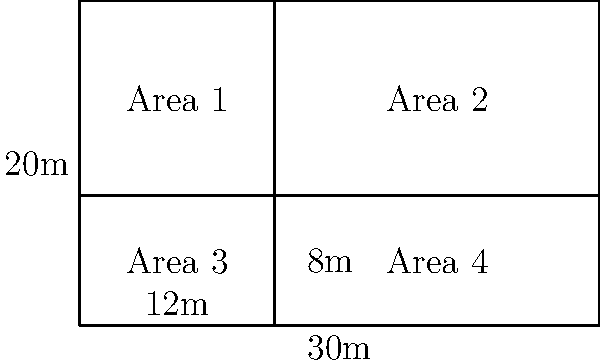A rectangular storage facility for ground support equipment needs to be divided into four areas. The facility measures 30m by 20m. Area 1 and Area 3 have a width of 12m, while Area 2 and Area 4 have a width of 18m. What is the total perimeter of all four storage areas combined? Let's approach this step-by-step:

1) First, let's identify the dimensions of each area:
   - Area 1 and Area 3: 12m × 8m
   - Area 2 and Area 4: 18m × 8m

2) Now, let's calculate the perimeter of each area:
   - For Area 1 and Area 3: $P = 2(12 + 8) = 40m$ each
   - For Area 2 and Area 4: $P = 2(18 + 8) = 52m$ each

3) The total perimeter would be the sum of all these, but we need to be careful not to double-count shared sides.

4) The outer perimeter of the entire facility is:
   $P_{outer} = 2(30 + 20) = 100m$

5) The internal dividing lines contribute to the perimeter:
   - The vertical line in the middle: 20m
   - The horizontal line: 30m

6) Therefore, the total perimeter is:
   $P_{total} = P_{outer} + P_{internal}$
   $P_{total} = 100m + 20m + 30m = 150m$
Answer: 150m 